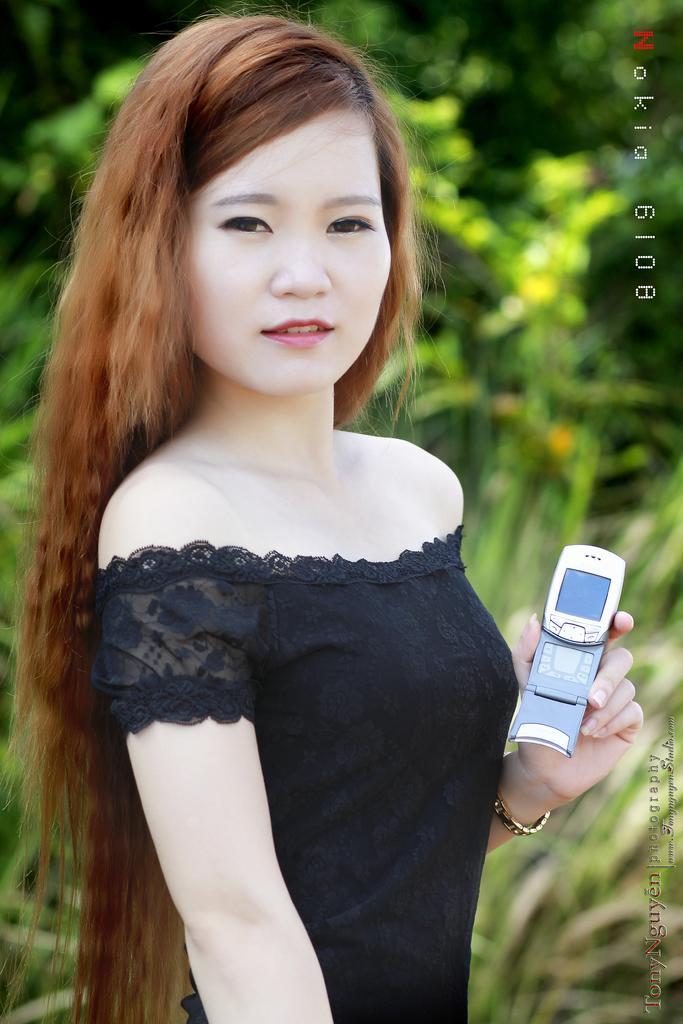How would you summarize this image in a sentence or two? In the center of the image, we can see a lady holding a mobile and in the background, there are trees and we can see some text. 